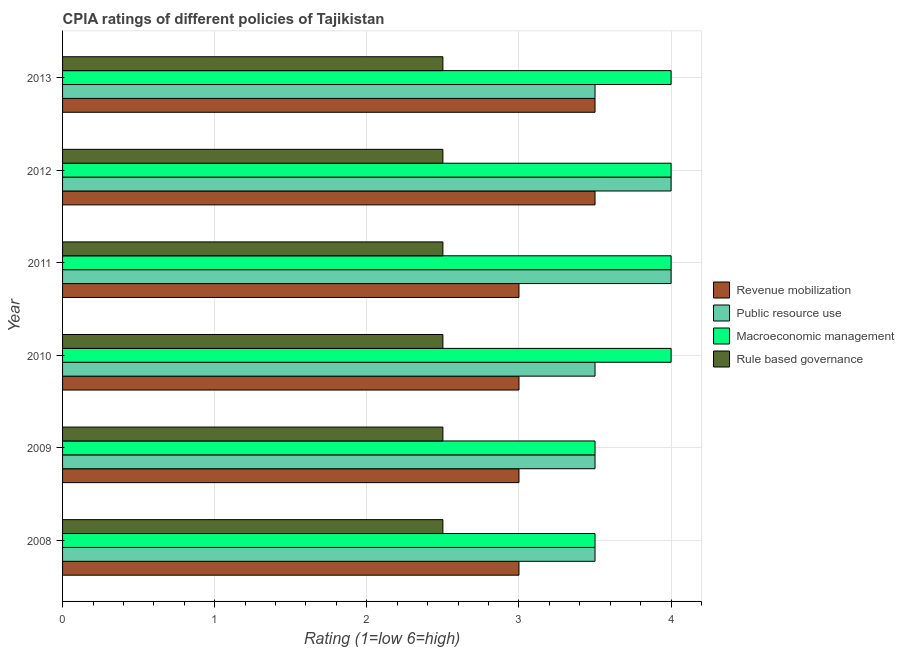Are the number of bars per tick equal to the number of legend labels?
Provide a short and direct response. Yes. Are the number of bars on each tick of the Y-axis equal?
Ensure brevity in your answer.  Yes. How many bars are there on the 2nd tick from the bottom?
Your answer should be very brief. 4. What is the cpia rating of revenue mobilization in 2008?
Your answer should be very brief. 3. Across all years, what is the maximum cpia rating of revenue mobilization?
Your answer should be compact. 3.5. What is the total cpia rating of public resource use in the graph?
Your answer should be very brief. 22. What is the average cpia rating of public resource use per year?
Offer a very short reply. 3.67. In how many years, is the cpia rating of revenue mobilization greater than 1.6 ?
Your answer should be very brief. 6. What is the ratio of the cpia rating of revenue mobilization in 2011 to that in 2013?
Keep it short and to the point. 0.86. Is the cpia rating of macroeconomic management in 2009 less than that in 2012?
Offer a very short reply. Yes. Is the difference between the cpia rating of revenue mobilization in 2008 and 2013 greater than the difference between the cpia rating of public resource use in 2008 and 2013?
Keep it short and to the point. No. What is the difference between the highest and the second highest cpia rating of macroeconomic management?
Offer a very short reply. 0. What is the difference between the highest and the lowest cpia rating of revenue mobilization?
Your response must be concise. 0.5. Is it the case that in every year, the sum of the cpia rating of macroeconomic management and cpia rating of public resource use is greater than the sum of cpia rating of rule based governance and cpia rating of revenue mobilization?
Make the answer very short. No. What does the 1st bar from the top in 2010 represents?
Make the answer very short. Rule based governance. What does the 2nd bar from the bottom in 2013 represents?
Offer a terse response. Public resource use. How many bars are there?
Your answer should be very brief. 24. Are all the bars in the graph horizontal?
Make the answer very short. Yes. Where does the legend appear in the graph?
Ensure brevity in your answer.  Center right. How many legend labels are there?
Provide a short and direct response. 4. What is the title of the graph?
Ensure brevity in your answer.  CPIA ratings of different policies of Tajikistan. What is the label or title of the X-axis?
Offer a very short reply. Rating (1=low 6=high). What is the Rating (1=low 6=high) of Public resource use in 2008?
Offer a very short reply. 3.5. What is the Rating (1=low 6=high) of Rule based governance in 2008?
Your response must be concise. 2.5. What is the Rating (1=low 6=high) of Rule based governance in 2010?
Offer a terse response. 2.5. What is the Rating (1=low 6=high) in Revenue mobilization in 2011?
Your answer should be very brief. 3. What is the Rating (1=low 6=high) of Public resource use in 2011?
Your answer should be very brief. 4. What is the Rating (1=low 6=high) in Macroeconomic management in 2011?
Keep it short and to the point. 4. What is the Rating (1=low 6=high) in Rule based governance in 2011?
Provide a succinct answer. 2.5. What is the Rating (1=low 6=high) in Revenue mobilization in 2012?
Your response must be concise. 3.5. What is the Rating (1=low 6=high) of Public resource use in 2012?
Give a very brief answer. 4. What is the Rating (1=low 6=high) in Public resource use in 2013?
Keep it short and to the point. 3.5. What is the Rating (1=low 6=high) in Macroeconomic management in 2013?
Keep it short and to the point. 4. What is the Rating (1=low 6=high) of Rule based governance in 2013?
Your answer should be compact. 2.5. Across all years, what is the maximum Rating (1=low 6=high) of Macroeconomic management?
Make the answer very short. 4. Across all years, what is the maximum Rating (1=low 6=high) of Rule based governance?
Offer a terse response. 2.5. Across all years, what is the minimum Rating (1=low 6=high) in Revenue mobilization?
Ensure brevity in your answer.  3. Across all years, what is the minimum Rating (1=low 6=high) of Public resource use?
Give a very brief answer. 3.5. Across all years, what is the minimum Rating (1=low 6=high) of Rule based governance?
Make the answer very short. 2.5. What is the total Rating (1=low 6=high) of Public resource use in the graph?
Your answer should be compact. 22. What is the total Rating (1=low 6=high) in Macroeconomic management in the graph?
Offer a very short reply. 23. What is the total Rating (1=low 6=high) in Rule based governance in the graph?
Ensure brevity in your answer.  15. What is the difference between the Rating (1=low 6=high) of Public resource use in 2008 and that in 2010?
Offer a very short reply. 0. What is the difference between the Rating (1=low 6=high) in Rule based governance in 2008 and that in 2010?
Your response must be concise. 0. What is the difference between the Rating (1=low 6=high) of Macroeconomic management in 2008 and that in 2012?
Your response must be concise. -0.5. What is the difference between the Rating (1=low 6=high) of Macroeconomic management in 2008 and that in 2013?
Your answer should be very brief. -0.5. What is the difference between the Rating (1=low 6=high) of Revenue mobilization in 2009 and that in 2010?
Provide a succinct answer. 0. What is the difference between the Rating (1=low 6=high) in Public resource use in 2009 and that in 2010?
Offer a very short reply. 0. What is the difference between the Rating (1=low 6=high) in Rule based governance in 2009 and that in 2010?
Offer a very short reply. 0. What is the difference between the Rating (1=low 6=high) of Macroeconomic management in 2009 and that in 2011?
Your response must be concise. -0.5. What is the difference between the Rating (1=low 6=high) in Public resource use in 2009 and that in 2012?
Make the answer very short. -0.5. What is the difference between the Rating (1=low 6=high) of Macroeconomic management in 2009 and that in 2012?
Provide a succinct answer. -0.5. What is the difference between the Rating (1=low 6=high) of Public resource use in 2009 and that in 2013?
Provide a short and direct response. 0. What is the difference between the Rating (1=low 6=high) of Macroeconomic management in 2010 and that in 2011?
Provide a short and direct response. 0. What is the difference between the Rating (1=low 6=high) of Rule based governance in 2010 and that in 2011?
Provide a short and direct response. 0. What is the difference between the Rating (1=low 6=high) in Revenue mobilization in 2010 and that in 2012?
Offer a terse response. -0.5. What is the difference between the Rating (1=low 6=high) in Public resource use in 2010 and that in 2012?
Your response must be concise. -0.5. What is the difference between the Rating (1=low 6=high) of Macroeconomic management in 2010 and that in 2012?
Your response must be concise. 0. What is the difference between the Rating (1=low 6=high) of Rule based governance in 2010 and that in 2012?
Your response must be concise. 0. What is the difference between the Rating (1=low 6=high) in Macroeconomic management in 2010 and that in 2013?
Your answer should be compact. 0. What is the difference between the Rating (1=low 6=high) in Rule based governance in 2010 and that in 2013?
Your response must be concise. 0. What is the difference between the Rating (1=low 6=high) in Public resource use in 2011 and that in 2012?
Ensure brevity in your answer.  0. What is the difference between the Rating (1=low 6=high) in Rule based governance in 2011 and that in 2012?
Ensure brevity in your answer.  0. What is the difference between the Rating (1=low 6=high) of Rule based governance in 2011 and that in 2013?
Your answer should be compact. 0. What is the difference between the Rating (1=low 6=high) of Revenue mobilization in 2012 and that in 2013?
Provide a succinct answer. 0. What is the difference between the Rating (1=low 6=high) in Rule based governance in 2012 and that in 2013?
Offer a terse response. 0. What is the difference between the Rating (1=low 6=high) of Macroeconomic management in 2008 and the Rating (1=low 6=high) of Rule based governance in 2009?
Offer a very short reply. 1. What is the difference between the Rating (1=low 6=high) of Revenue mobilization in 2008 and the Rating (1=low 6=high) of Rule based governance in 2010?
Your answer should be very brief. 0.5. What is the difference between the Rating (1=low 6=high) in Public resource use in 2008 and the Rating (1=low 6=high) in Rule based governance in 2010?
Your response must be concise. 1. What is the difference between the Rating (1=low 6=high) in Revenue mobilization in 2008 and the Rating (1=low 6=high) in Public resource use in 2011?
Your answer should be very brief. -1. What is the difference between the Rating (1=low 6=high) in Revenue mobilization in 2008 and the Rating (1=low 6=high) in Macroeconomic management in 2011?
Offer a terse response. -1. What is the difference between the Rating (1=low 6=high) in Revenue mobilization in 2008 and the Rating (1=low 6=high) in Rule based governance in 2011?
Provide a succinct answer. 0.5. What is the difference between the Rating (1=low 6=high) in Macroeconomic management in 2008 and the Rating (1=low 6=high) in Rule based governance in 2011?
Make the answer very short. 1. What is the difference between the Rating (1=low 6=high) in Revenue mobilization in 2008 and the Rating (1=low 6=high) in Public resource use in 2012?
Give a very brief answer. -1. What is the difference between the Rating (1=low 6=high) in Public resource use in 2008 and the Rating (1=low 6=high) in Macroeconomic management in 2012?
Give a very brief answer. -0.5. What is the difference between the Rating (1=low 6=high) of Macroeconomic management in 2008 and the Rating (1=low 6=high) of Rule based governance in 2012?
Your answer should be very brief. 1. What is the difference between the Rating (1=low 6=high) in Revenue mobilization in 2008 and the Rating (1=low 6=high) in Macroeconomic management in 2013?
Provide a succinct answer. -1. What is the difference between the Rating (1=low 6=high) in Revenue mobilization in 2008 and the Rating (1=low 6=high) in Rule based governance in 2013?
Provide a short and direct response. 0.5. What is the difference between the Rating (1=low 6=high) in Public resource use in 2008 and the Rating (1=low 6=high) in Macroeconomic management in 2013?
Your response must be concise. -0.5. What is the difference between the Rating (1=low 6=high) of Revenue mobilization in 2009 and the Rating (1=low 6=high) of Public resource use in 2010?
Provide a succinct answer. -0.5. What is the difference between the Rating (1=low 6=high) in Revenue mobilization in 2009 and the Rating (1=low 6=high) in Rule based governance in 2010?
Your answer should be very brief. 0.5. What is the difference between the Rating (1=low 6=high) in Macroeconomic management in 2009 and the Rating (1=low 6=high) in Rule based governance in 2010?
Provide a short and direct response. 1. What is the difference between the Rating (1=low 6=high) of Revenue mobilization in 2009 and the Rating (1=low 6=high) of Macroeconomic management in 2011?
Ensure brevity in your answer.  -1. What is the difference between the Rating (1=low 6=high) in Public resource use in 2009 and the Rating (1=low 6=high) in Rule based governance in 2011?
Your answer should be compact. 1. What is the difference between the Rating (1=low 6=high) in Revenue mobilization in 2009 and the Rating (1=low 6=high) in Public resource use in 2012?
Give a very brief answer. -1. What is the difference between the Rating (1=low 6=high) of Revenue mobilization in 2009 and the Rating (1=low 6=high) of Macroeconomic management in 2012?
Ensure brevity in your answer.  -1. What is the difference between the Rating (1=low 6=high) in Revenue mobilization in 2009 and the Rating (1=low 6=high) in Rule based governance in 2012?
Provide a short and direct response. 0.5. What is the difference between the Rating (1=low 6=high) in Public resource use in 2009 and the Rating (1=low 6=high) in Macroeconomic management in 2012?
Ensure brevity in your answer.  -0.5. What is the difference between the Rating (1=low 6=high) of Revenue mobilization in 2009 and the Rating (1=low 6=high) of Rule based governance in 2013?
Keep it short and to the point. 0.5. What is the difference between the Rating (1=low 6=high) of Public resource use in 2009 and the Rating (1=low 6=high) of Macroeconomic management in 2013?
Make the answer very short. -0.5. What is the difference between the Rating (1=low 6=high) of Public resource use in 2009 and the Rating (1=low 6=high) of Rule based governance in 2013?
Keep it short and to the point. 1. What is the difference between the Rating (1=low 6=high) of Macroeconomic management in 2009 and the Rating (1=low 6=high) of Rule based governance in 2013?
Provide a short and direct response. 1. What is the difference between the Rating (1=low 6=high) in Revenue mobilization in 2010 and the Rating (1=low 6=high) in Macroeconomic management in 2011?
Offer a terse response. -1. What is the difference between the Rating (1=low 6=high) in Public resource use in 2010 and the Rating (1=low 6=high) in Macroeconomic management in 2011?
Give a very brief answer. -0.5. What is the difference between the Rating (1=low 6=high) of Revenue mobilization in 2010 and the Rating (1=low 6=high) of Public resource use in 2012?
Provide a succinct answer. -1. What is the difference between the Rating (1=low 6=high) of Revenue mobilization in 2010 and the Rating (1=low 6=high) of Macroeconomic management in 2012?
Provide a short and direct response. -1. What is the difference between the Rating (1=low 6=high) in Revenue mobilization in 2010 and the Rating (1=low 6=high) in Rule based governance in 2012?
Provide a short and direct response. 0.5. What is the difference between the Rating (1=low 6=high) of Public resource use in 2010 and the Rating (1=low 6=high) of Macroeconomic management in 2012?
Offer a terse response. -0.5. What is the difference between the Rating (1=low 6=high) of Public resource use in 2010 and the Rating (1=low 6=high) of Rule based governance in 2012?
Make the answer very short. 1. What is the difference between the Rating (1=low 6=high) in Revenue mobilization in 2010 and the Rating (1=low 6=high) in Public resource use in 2013?
Provide a short and direct response. -0.5. What is the difference between the Rating (1=low 6=high) in Revenue mobilization in 2010 and the Rating (1=low 6=high) in Rule based governance in 2013?
Your answer should be very brief. 0.5. What is the difference between the Rating (1=low 6=high) of Public resource use in 2010 and the Rating (1=low 6=high) of Macroeconomic management in 2013?
Offer a very short reply. -0.5. What is the difference between the Rating (1=low 6=high) of Public resource use in 2010 and the Rating (1=low 6=high) of Rule based governance in 2013?
Your answer should be very brief. 1. What is the difference between the Rating (1=low 6=high) in Public resource use in 2011 and the Rating (1=low 6=high) in Macroeconomic management in 2012?
Provide a short and direct response. 0. What is the difference between the Rating (1=low 6=high) of Macroeconomic management in 2011 and the Rating (1=low 6=high) of Rule based governance in 2012?
Give a very brief answer. 1.5. What is the difference between the Rating (1=low 6=high) of Revenue mobilization in 2011 and the Rating (1=low 6=high) of Public resource use in 2013?
Make the answer very short. -0.5. What is the difference between the Rating (1=low 6=high) in Revenue mobilization in 2011 and the Rating (1=low 6=high) in Macroeconomic management in 2013?
Offer a terse response. -1. What is the difference between the Rating (1=low 6=high) of Public resource use in 2011 and the Rating (1=low 6=high) of Rule based governance in 2013?
Provide a succinct answer. 1.5. What is the difference between the Rating (1=low 6=high) in Revenue mobilization in 2012 and the Rating (1=low 6=high) in Macroeconomic management in 2013?
Offer a terse response. -0.5. What is the difference between the Rating (1=low 6=high) in Public resource use in 2012 and the Rating (1=low 6=high) in Macroeconomic management in 2013?
Provide a short and direct response. 0. What is the difference between the Rating (1=low 6=high) in Macroeconomic management in 2012 and the Rating (1=low 6=high) in Rule based governance in 2013?
Make the answer very short. 1.5. What is the average Rating (1=low 6=high) in Revenue mobilization per year?
Make the answer very short. 3.17. What is the average Rating (1=low 6=high) of Public resource use per year?
Your response must be concise. 3.67. What is the average Rating (1=low 6=high) of Macroeconomic management per year?
Offer a terse response. 3.83. In the year 2008, what is the difference between the Rating (1=low 6=high) in Revenue mobilization and Rating (1=low 6=high) in Macroeconomic management?
Offer a terse response. -0.5. In the year 2008, what is the difference between the Rating (1=low 6=high) in Revenue mobilization and Rating (1=low 6=high) in Rule based governance?
Give a very brief answer. 0.5. In the year 2008, what is the difference between the Rating (1=low 6=high) in Public resource use and Rating (1=low 6=high) in Rule based governance?
Your answer should be compact. 1. In the year 2008, what is the difference between the Rating (1=low 6=high) of Macroeconomic management and Rating (1=low 6=high) of Rule based governance?
Offer a terse response. 1. In the year 2009, what is the difference between the Rating (1=low 6=high) of Macroeconomic management and Rating (1=low 6=high) of Rule based governance?
Give a very brief answer. 1. In the year 2010, what is the difference between the Rating (1=low 6=high) of Revenue mobilization and Rating (1=low 6=high) of Public resource use?
Your answer should be compact. -0.5. In the year 2010, what is the difference between the Rating (1=low 6=high) in Revenue mobilization and Rating (1=low 6=high) in Macroeconomic management?
Give a very brief answer. -1. In the year 2010, what is the difference between the Rating (1=low 6=high) of Revenue mobilization and Rating (1=low 6=high) of Rule based governance?
Provide a short and direct response. 0.5. In the year 2010, what is the difference between the Rating (1=low 6=high) of Public resource use and Rating (1=low 6=high) of Rule based governance?
Your response must be concise. 1. In the year 2011, what is the difference between the Rating (1=low 6=high) in Revenue mobilization and Rating (1=low 6=high) in Macroeconomic management?
Your answer should be very brief. -1. In the year 2011, what is the difference between the Rating (1=low 6=high) of Revenue mobilization and Rating (1=low 6=high) of Rule based governance?
Ensure brevity in your answer.  0.5. In the year 2012, what is the difference between the Rating (1=low 6=high) in Public resource use and Rating (1=low 6=high) in Macroeconomic management?
Keep it short and to the point. 0. In the year 2012, what is the difference between the Rating (1=low 6=high) of Public resource use and Rating (1=low 6=high) of Rule based governance?
Offer a terse response. 1.5. In the year 2013, what is the difference between the Rating (1=low 6=high) of Revenue mobilization and Rating (1=low 6=high) of Rule based governance?
Provide a succinct answer. 1. In the year 2013, what is the difference between the Rating (1=low 6=high) in Public resource use and Rating (1=low 6=high) in Rule based governance?
Keep it short and to the point. 1. In the year 2013, what is the difference between the Rating (1=low 6=high) of Macroeconomic management and Rating (1=low 6=high) of Rule based governance?
Your answer should be very brief. 1.5. What is the ratio of the Rating (1=low 6=high) in Macroeconomic management in 2008 to that in 2009?
Keep it short and to the point. 1. What is the ratio of the Rating (1=low 6=high) of Rule based governance in 2008 to that in 2010?
Offer a very short reply. 1. What is the ratio of the Rating (1=low 6=high) of Rule based governance in 2008 to that in 2011?
Provide a short and direct response. 1. What is the ratio of the Rating (1=low 6=high) in Revenue mobilization in 2008 to that in 2012?
Ensure brevity in your answer.  0.86. What is the ratio of the Rating (1=low 6=high) of Public resource use in 2008 to that in 2012?
Offer a terse response. 0.88. What is the ratio of the Rating (1=low 6=high) of Macroeconomic management in 2008 to that in 2012?
Ensure brevity in your answer.  0.88. What is the ratio of the Rating (1=low 6=high) of Macroeconomic management in 2008 to that in 2013?
Keep it short and to the point. 0.88. What is the ratio of the Rating (1=low 6=high) in Revenue mobilization in 2009 to that in 2010?
Your answer should be compact. 1. What is the ratio of the Rating (1=low 6=high) in Public resource use in 2009 to that in 2010?
Provide a succinct answer. 1. What is the ratio of the Rating (1=low 6=high) in Macroeconomic management in 2009 to that in 2010?
Provide a short and direct response. 0.88. What is the ratio of the Rating (1=low 6=high) in Rule based governance in 2009 to that in 2010?
Your response must be concise. 1. What is the ratio of the Rating (1=low 6=high) in Macroeconomic management in 2009 to that in 2011?
Offer a very short reply. 0.88. What is the ratio of the Rating (1=low 6=high) in Rule based governance in 2009 to that in 2011?
Offer a very short reply. 1. What is the ratio of the Rating (1=low 6=high) in Revenue mobilization in 2009 to that in 2013?
Provide a short and direct response. 0.86. What is the ratio of the Rating (1=low 6=high) of Public resource use in 2009 to that in 2013?
Ensure brevity in your answer.  1. What is the ratio of the Rating (1=low 6=high) of Rule based governance in 2009 to that in 2013?
Provide a succinct answer. 1. What is the ratio of the Rating (1=low 6=high) of Revenue mobilization in 2010 to that in 2011?
Provide a short and direct response. 1. What is the ratio of the Rating (1=low 6=high) in Public resource use in 2010 to that in 2011?
Provide a short and direct response. 0.88. What is the ratio of the Rating (1=low 6=high) in Macroeconomic management in 2010 to that in 2011?
Provide a short and direct response. 1. What is the ratio of the Rating (1=low 6=high) of Revenue mobilization in 2010 to that in 2012?
Keep it short and to the point. 0.86. What is the ratio of the Rating (1=low 6=high) of Macroeconomic management in 2010 to that in 2012?
Your answer should be very brief. 1. What is the ratio of the Rating (1=low 6=high) in Rule based governance in 2010 to that in 2012?
Provide a short and direct response. 1. What is the ratio of the Rating (1=low 6=high) in Public resource use in 2010 to that in 2013?
Give a very brief answer. 1. What is the ratio of the Rating (1=low 6=high) of Revenue mobilization in 2011 to that in 2012?
Your response must be concise. 0.86. What is the ratio of the Rating (1=low 6=high) of Public resource use in 2011 to that in 2012?
Your answer should be very brief. 1. What is the ratio of the Rating (1=low 6=high) of Macroeconomic management in 2011 to that in 2012?
Offer a very short reply. 1. What is the ratio of the Rating (1=low 6=high) of Rule based governance in 2011 to that in 2012?
Keep it short and to the point. 1. What is the ratio of the Rating (1=low 6=high) of Public resource use in 2012 to that in 2013?
Ensure brevity in your answer.  1.14. What is the ratio of the Rating (1=low 6=high) in Macroeconomic management in 2012 to that in 2013?
Offer a very short reply. 1. What is the ratio of the Rating (1=low 6=high) in Rule based governance in 2012 to that in 2013?
Keep it short and to the point. 1. What is the difference between the highest and the second highest Rating (1=low 6=high) of Revenue mobilization?
Offer a terse response. 0. What is the difference between the highest and the second highest Rating (1=low 6=high) in Public resource use?
Make the answer very short. 0. What is the difference between the highest and the second highest Rating (1=low 6=high) of Macroeconomic management?
Provide a succinct answer. 0. What is the difference between the highest and the lowest Rating (1=low 6=high) in Revenue mobilization?
Offer a terse response. 0.5. What is the difference between the highest and the lowest Rating (1=low 6=high) in Public resource use?
Provide a succinct answer. 0.5. What is the difference between the highest and the lowest Rating (1=low 6=high) in Macroeconomic management?
Make the answer very short. 0.5. 